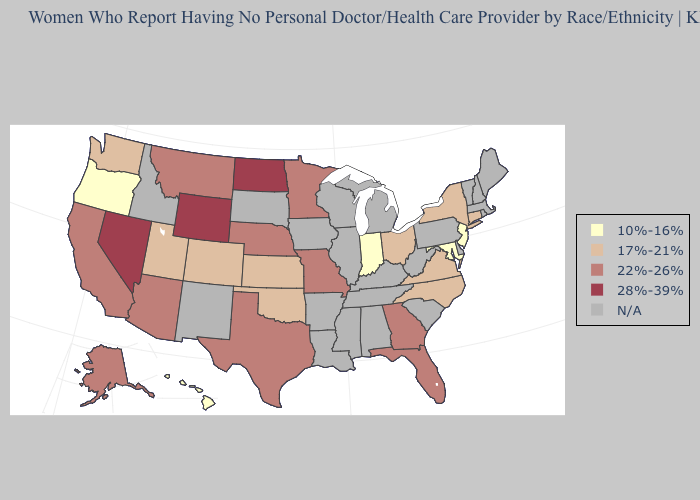Which states have the lowest value in the MidWest?
Give a very brief answer. Indiana. Name the states that have a value in the range N/A?
Give a very brief answer. Alabama, Arkansas, Delaware, Idaho, Illinois, Iowa, Kentucky, Louisiana, Maine, Massachusetts, Michigan, Mississippi, New Hampshire, New Mexico, Pennsylvania, Rhode Island, South Carolina, South Dakota, Tennessee, Vermont, West Virginia, Wisconsin. Does Utah have the highest value in the USA?
Short answer required. No. What is the value of Maine?
Short answer required. N/A. Which states have the lowest value in the MidWest?
Quick response, please. Indiana. Among the states that border West Virginia , which have the highest value?
Quick response, please. Ohio, Virginia. Name the states that have a value in the range 22%-26%?
Give a very brief answer. Alaska, Arizona, California, Florida, Georgia, Minnesota, Missouri, Montana, Nebraska, Texas. What is the value of Wyoming?
Keep it brief. 28%-39%. What is the value of Wisconsin?
Quick response, please. N/A. Name the states that have a value in the range 10%-16%?
Short answer required. Hawaii, Indiana, Maryland, New Jersey, Oregon. Which states have the lowest value in the USA?
Concise answer only. Hawaii, Indiana, Maryland, New Jersey, Oregon. Does North Dakota have the highest value in the MidWest?
Answer briefly. Yes. What is the value of Oklahoma?
Write a very short answer. 17%-21%. 